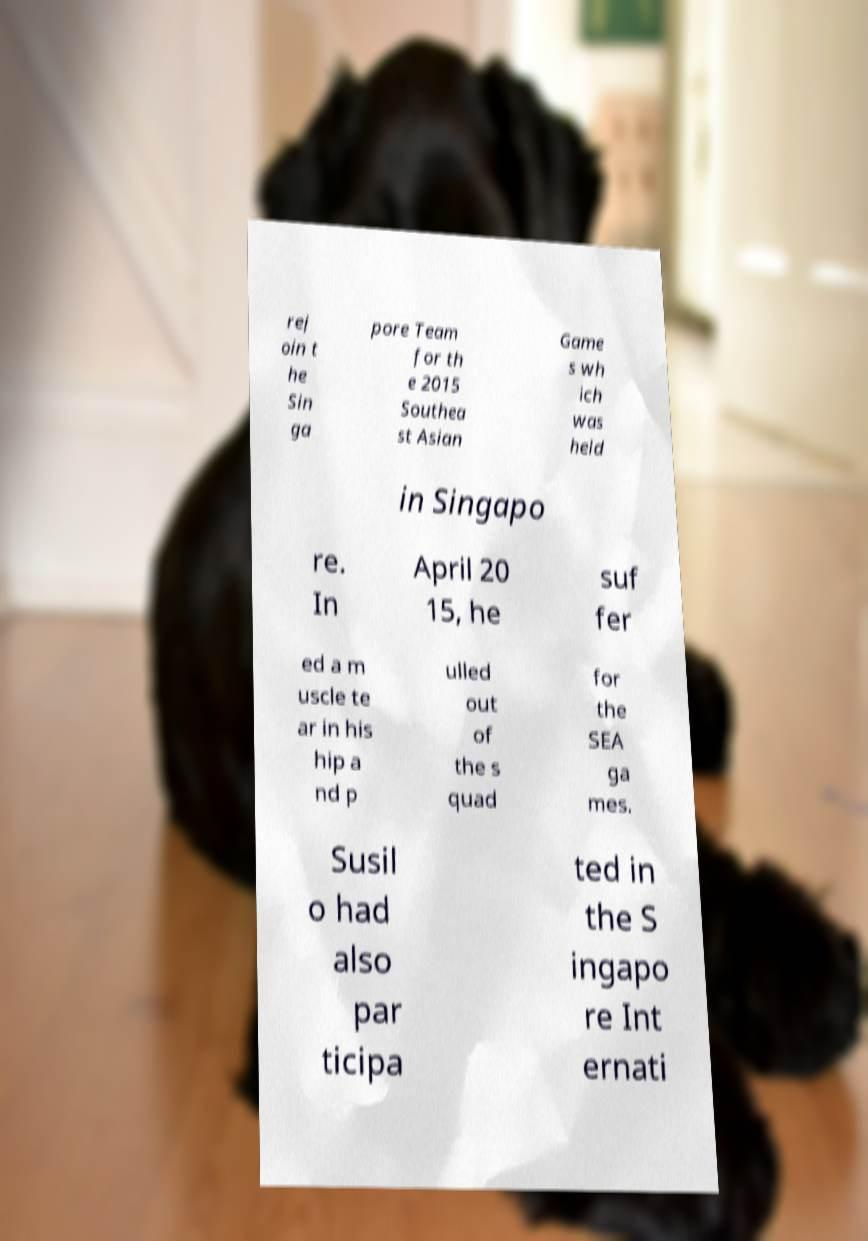Please read and relay the text visible in this image. What does it say? rej oin t he Sin ga pore Team for th e 2015 Southea st Asian Game s wh ich was held in Singapo re. In April 20 15, he suf fer ed a m uscle te ar in his hip a nd p ulled out of the s quad for the SEA ga mes. Susil o had also par ticipa ted in the S ingapo re Int ernati 